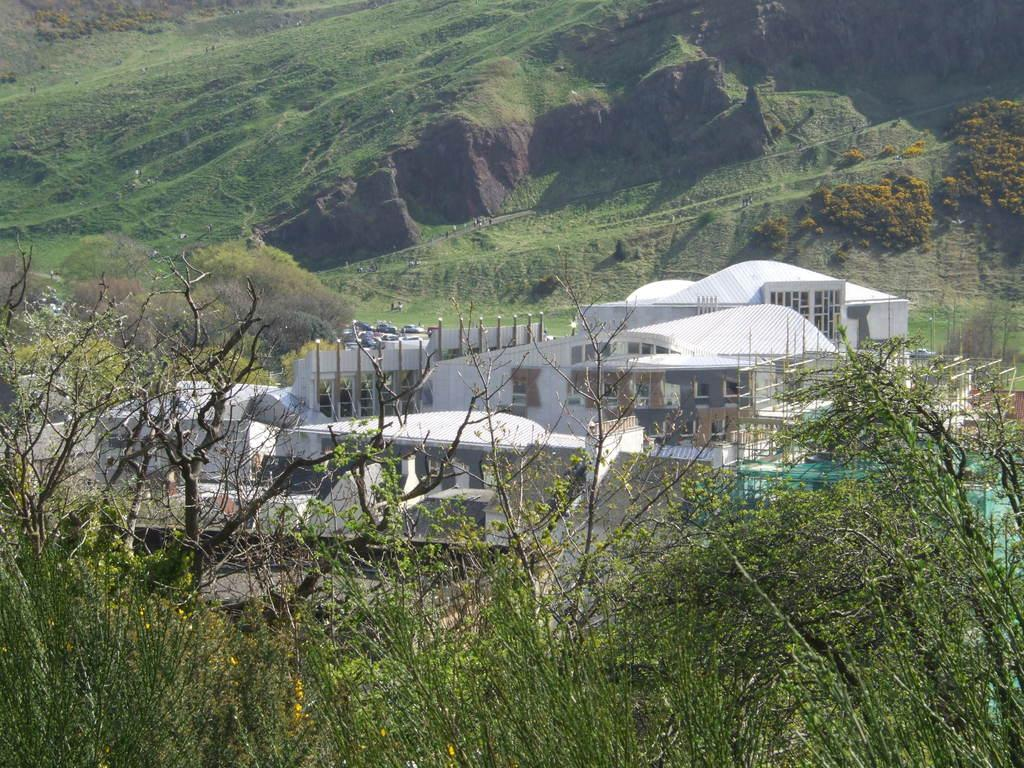What objects can be seen on the plates in the image? The provided facts do not specify what is on the plates. What type of flowers are present in the image? There are yellow color flowers in the image. What is the color of the building in the image? The building in the image is white in color. What natural feature can be seen in the background of the image? There are mountains visible in the background of the image. How many patches are on the parent's shirt in the image? There is no parent or shirt mentioned in the provided facts, so this question cannot be answered. 